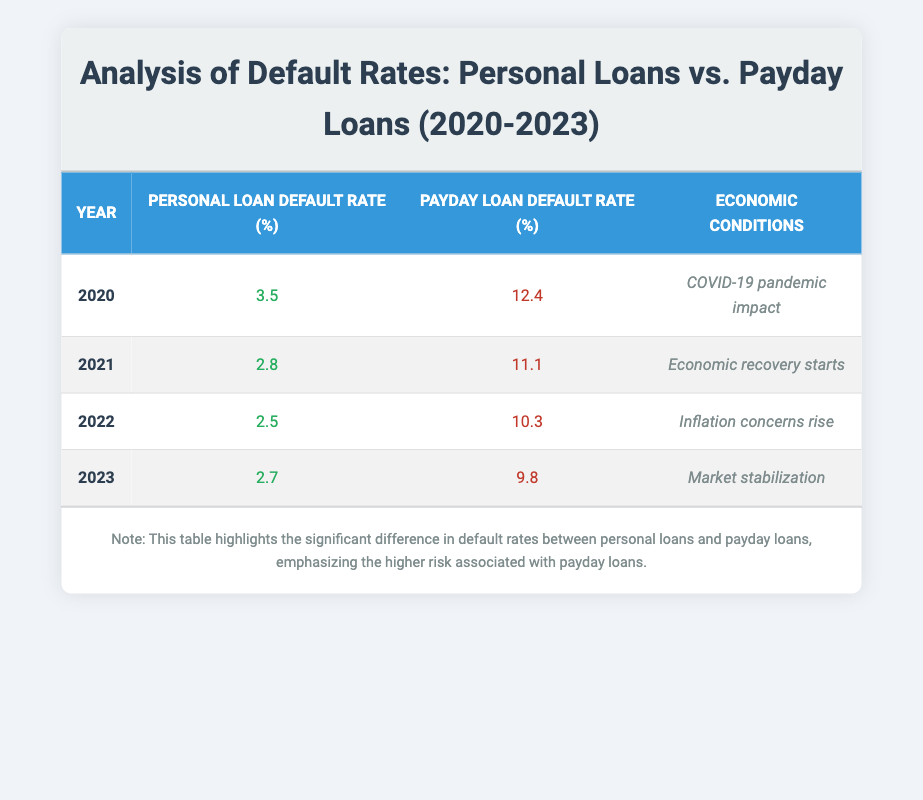What was the personal loan default rate in 2020? From the table, we can directly see that the personal loan default rate for the year 2020 is listed as 3.5%.
Answer: 3.5% What was the difference in default rates between personal loans and payday loans in 2021? In 2021, the personal loan default rate was 2.8% and the payday loan default rate was 11.1%. The difference is calculated as 11.1% - 2.8% = 8.3%.
Answer: 8.3% Did the default rate for payday loans decrease every year from 2020 to 2023? Looking at the data, the payday loan default rates are 12.4% in 2020, 11.1% in 2021, 10.3% in 2022, and 9.8% in 2023. Each year, the payday loan default rate decreased, confirming that it did decrease every year.
Answer: Yes What was the average personal loan default rate from 2020 to 2023? The personal loan default rates for the years 2020, 2021, 2022, and 2023 are 3.5%, 2.8%, 2.5%, and 2.7%. First, we sum these values: 3.5 + 2.8 + 2.5 + 2.7 = 11.5%. There are four years, so we then divide by 4: 11.5% / 4 = 2.875%.
Answer: 2.875% In which year was the default rate for personal loans the lowest? By examining the personal loan default rates for each year, 3.5% in 2020, 2.8% in 2021, 2.5% in 2022, and 2.7% in 2023, we can see that 2.5% in 2022 is the lowest rate recorded.
Answer: 2022 What was the economic condition in 2022? The table states that the economic conditions for the year 2022 were characterized by rising inflation concerns.
Answer: Inflation concerns rise What was the overall trend for personal loan default rates from 2020 to 2023? Observing the personal loan default rates listed for each year: 3.5% in 2020, 2.8% in 2021, 2.5% in 2022, and 2.7% in 2023, we can see a decreasing trend until 2022, followed by a slight increase in 2023. However, the overall trend is still a decrease from 2020 to 2022.
Answer: Decrease until 2022, slight increase in 2023 Is the payday loan default rate higher than the personal loan default rate in all observed years? By comparing the payday loan and personal loan default rates for each year: In 2020 (12.4% vs. 3.5%), 2021 (11.1% vs. 2.8%), 2022 (10.3% vs. 2.5%), and 2023 (9.8% vs. 2.7%), payday loans consistently have a higher default rate for every year.
Answer: Yes 